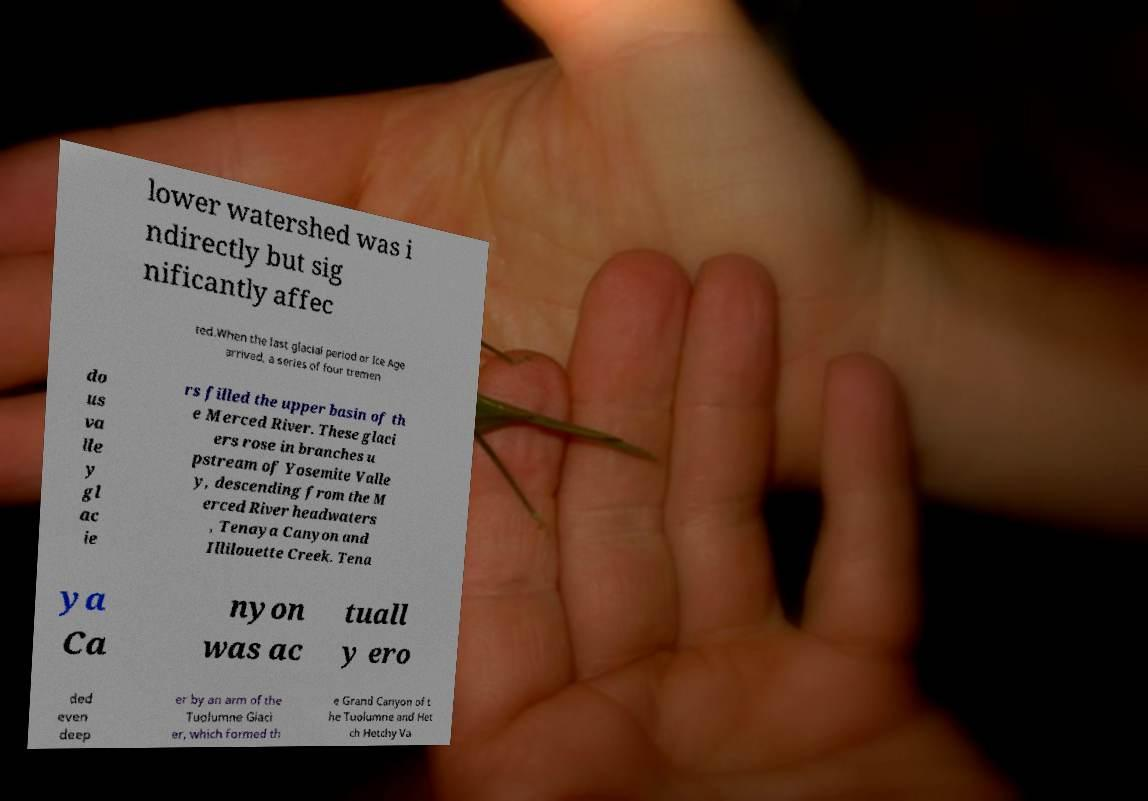Please read and relay the text visible in this image. What does it say? lower watershed was i ndirectly but sig nificantly affec ted.When the last glacial period or Ice Age arrived, a series of four tremen do us va lle y gl ac ie rs filled the upper basin of th e Merced River. These glaci ers rose in branches u pstream of Yosemite Valle y, descending from the M erced River headwaters , Tenaya Canyon and Illilouette Creek. Tena ya Ca nyon was ac tuall y ero ded even deep er by an arm of the Tuolumne Glaci er, which formed th e Grand Canyon of t he Tuolumne and Het ch Hetchy Va 